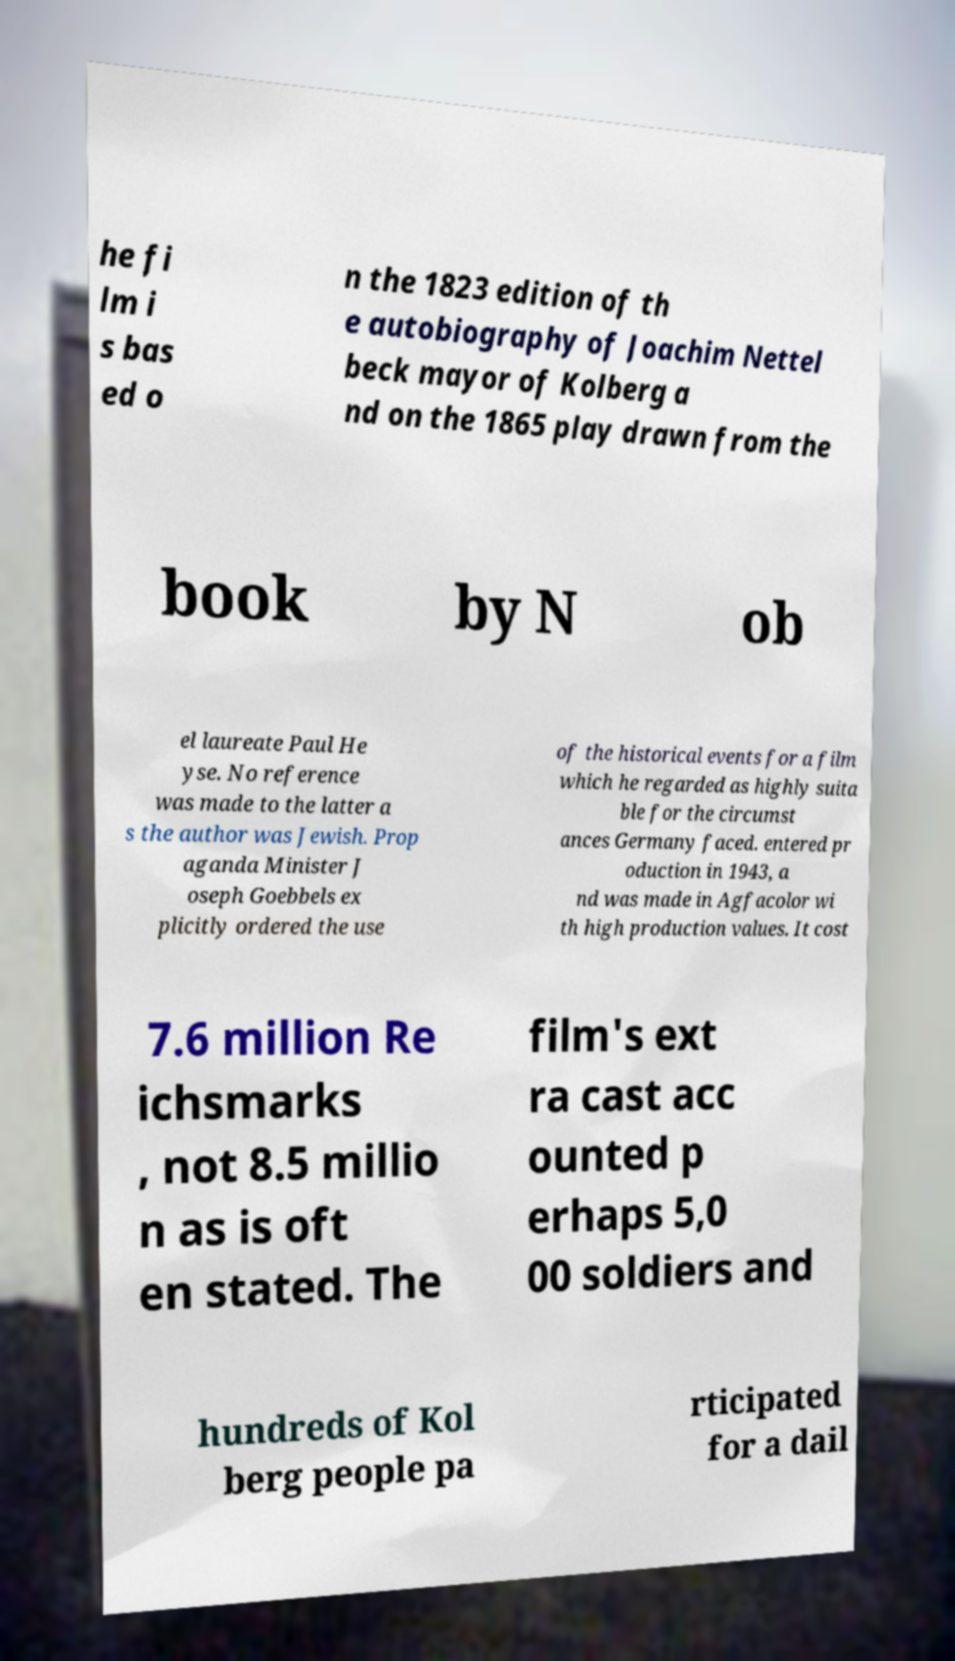Can you read and provide the text displayed in the image?This photo seems to have some interesting text. Can you extract and type it out for me? he fi lm i s bas ed o n the 1823 edition of th e autobiography of Joachim Nettel beck mayor of Kolberg a nd on the 1865 play drawn from the book by N ob el laureate Paul He yse. No reference was made to the latter a s the author was Jewish. Prop aganda Minister J oseph Goebbels ex plicitly ordered the use of the historical events for a film which he regarded as highly suita ble for the circumst ances Germany faced. entered pr oduction in 1943, a nd was made in Agfacolor wi th high production values. It cost 7.6 million Re ichsmarks , not 8.5 millio n as is oft en stated. The film's ext ra cast acc ounted p erhaps 5,0 00 soldiers and hundreds of Kol berg people pa rticipated for a dail 